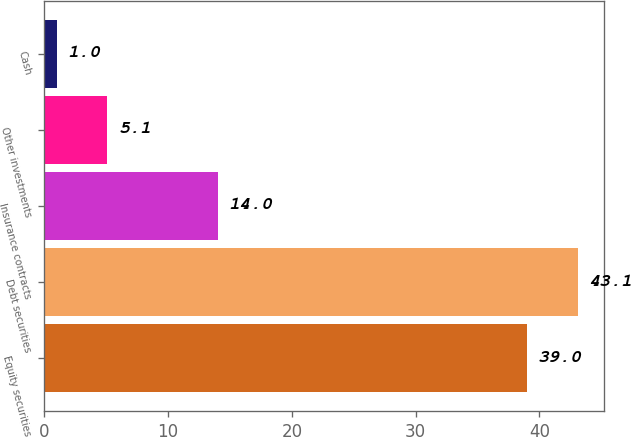Convert chart. <chart><loc_0><loc_0><loc_500><loc_500><bar_chart><fcel>Equity securities<fcel>Debt securities<fcel>Insurance contracts<fcel>Other investments<fcel>Cash<nl><fcel>39<fcel>43.1<fcel>14<fcel>5.1<fcel>1<nl></chart> 